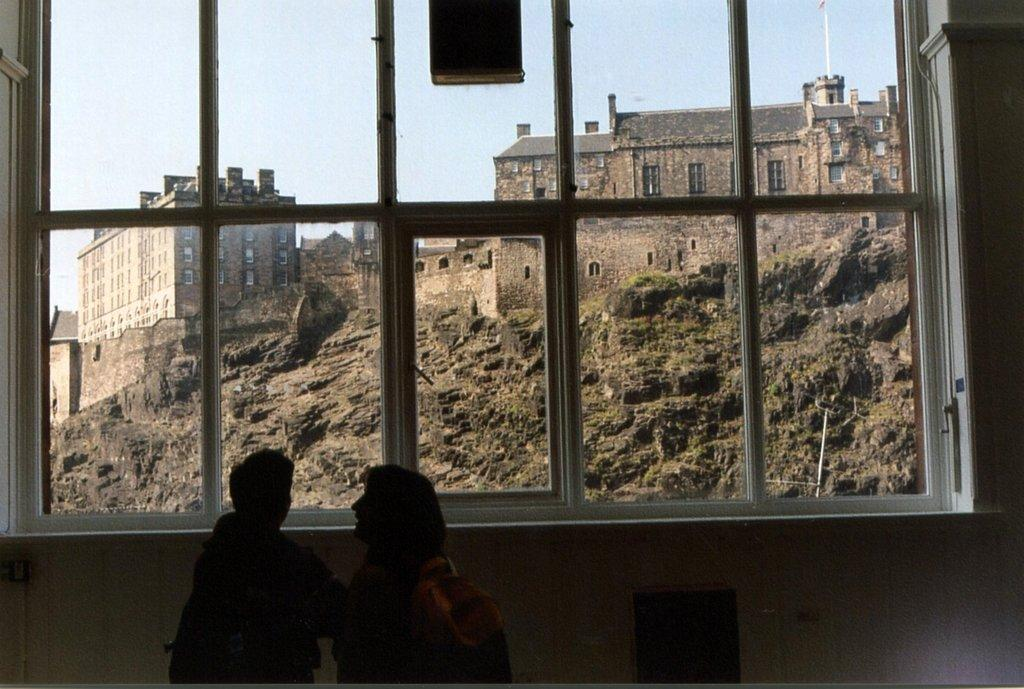What is located in the center of the image? There is a wall in the center of the image. What can be seen through the glass window in the image? The sky, buildings, windows, a roof, and another wall are visible through the glass window. How many people are present in the image? Two persons are standing in the image. What type of apparel is the mouth wearing in the image? There is no mouth or apparel present in the image. Can you describe the clouds visible through the glass window? There are no clouds visible through the glass window in the image. 